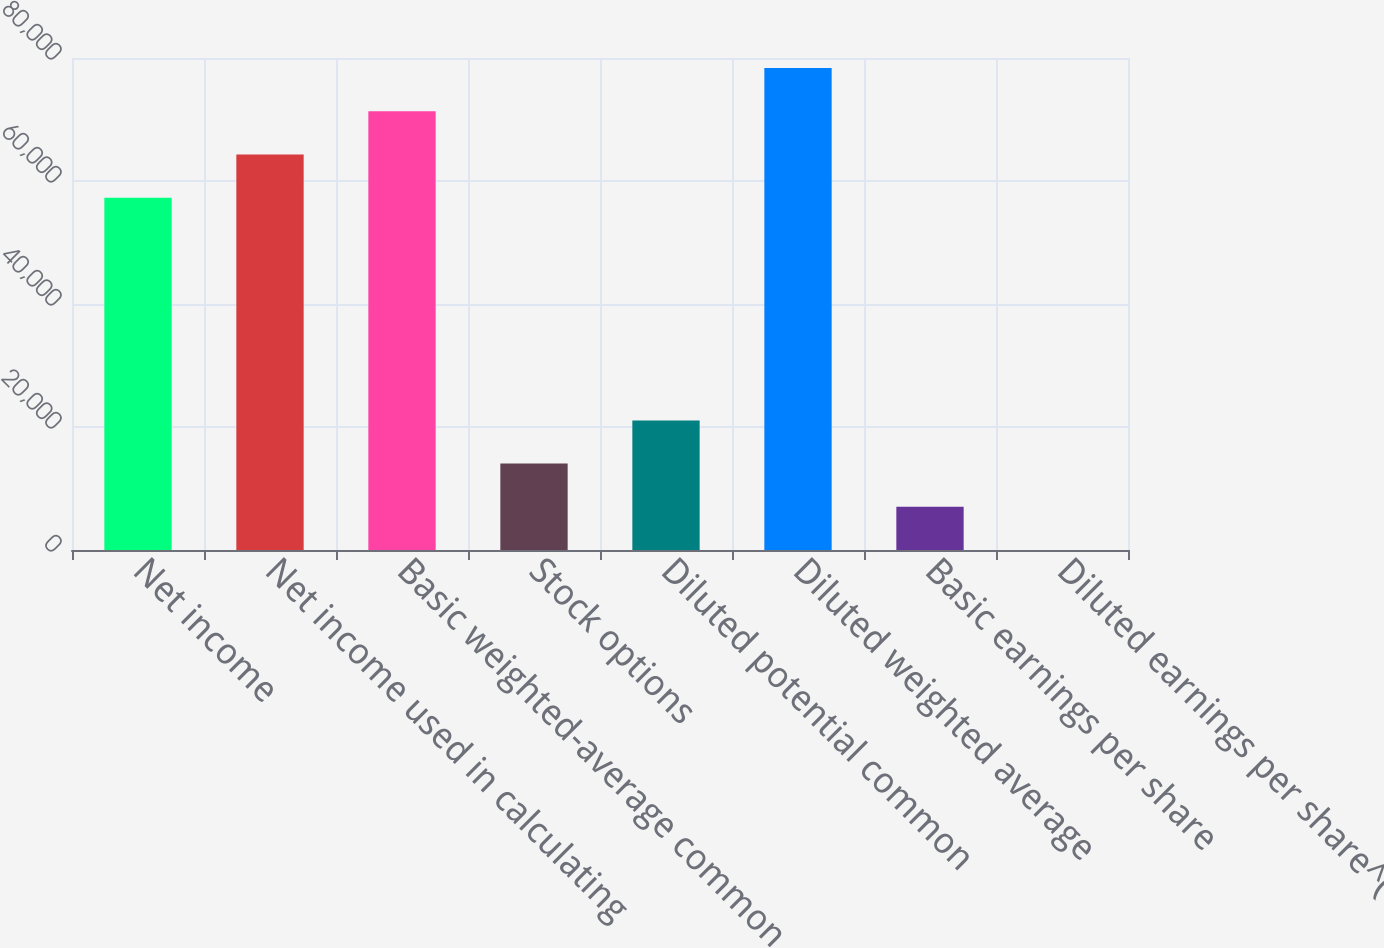Convert chart. <chart><loc_0><loc_0><loc_500><loc_500><bar_chart><fcel>Net income<fcel>Net income used in calculating<fcel>Basic weighted-average common<fcel>Stock options<fcel>Diluted potential common<fcel>Diluted weighted average<fcel>Basic earnings per share<fcel>Diluted earnings per share^(1)<nl><fcel>57284<fcel>64309<fcel>71334<fcel>14050.9<fcel>21075.9<fcel>78359.1<fcel>7025.84<fcel>0.82<nl></chart> 